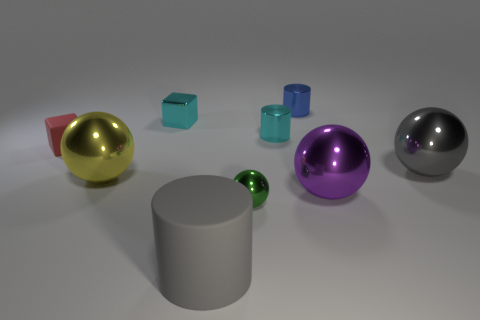What is the shape of the object that is the same color as the big cylinder?
Provide a succinct answer. Sphere. How many objects are red blocks or spheres that are on the right side of the tiny blue metal thing?
Offer a terse response. 3. The large thing that is left of the large gray cylinder is what color?
Make the answer very short. Yellow. Is the size of the metallic cylinder that is in front of the blue thing the same as the gray thing that is to the right of the tiny blue metal object?
Your answer should be compact. No. Are there any gray rubber things of the same size as the purple metal thing?
Provide a succinct answer. Yes. How many cyan metallic cylinders are in front of the rubber thing to the right of the cyan block?
Your response must be concise. 0. What is the red block made of?
Provide a short and direct response. Rubber. There is a small cyan cylinder; what number of tiny green metallic spheres are right of it?
Offer a very short reply. 0. How many big metal spheres have the same color as the matte block?
Your answer should be very brief. 0. Is the number of small rubber cylinders greater than the number of yellow spheres?
Give a very brief answer. No. 